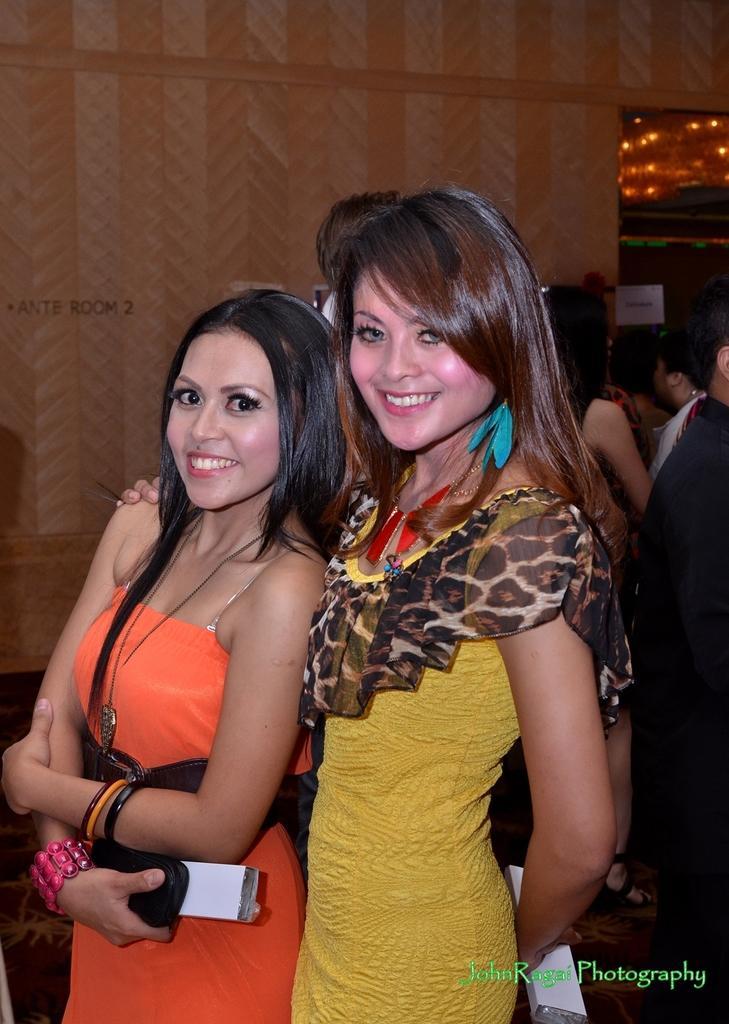Describe this image in one or two sentences. In the given picture, I can see two women's and a women wearing a orange color dress and holding a mobile , smiling and there is other women. She is holding her friend and smiling after that behind those people i can see few people and lights which are fixed to the roof and also a wall. 